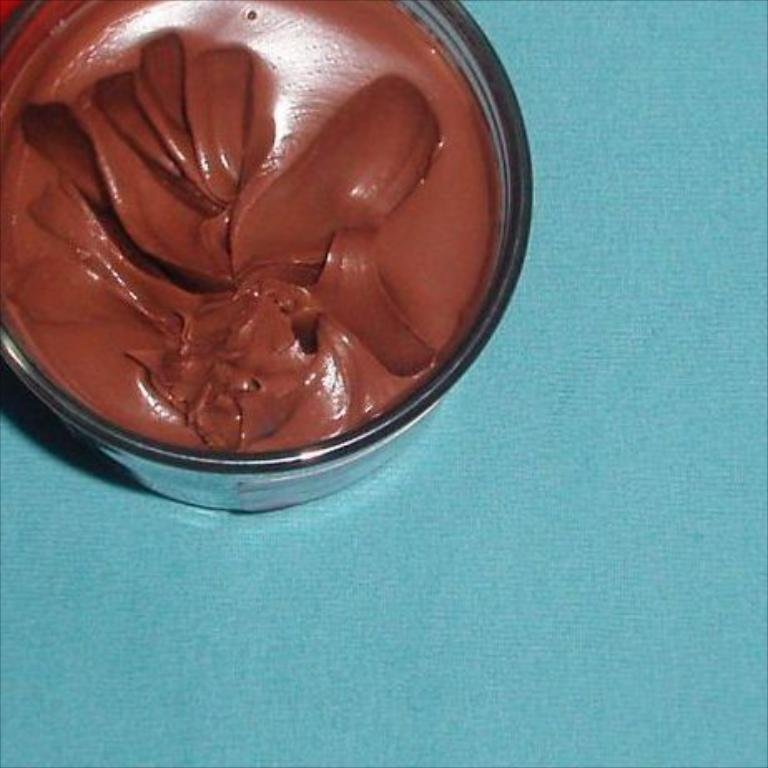What is the main subject of the image? There is a food item in the image. How is the food item contained in the image? The food item is in a bowl. What color is the surface on which the bowl is placed? The bowl is on a blue-colored surface. What type of organization is depicted in the image? There is no organization present in the image; it features a food item in a bowl on a blue-colored surface. Can you tell me how many clouds are visible in the image? There are no clouds visible in the image; it features a food item in a bowl on a blue-colored surface. 